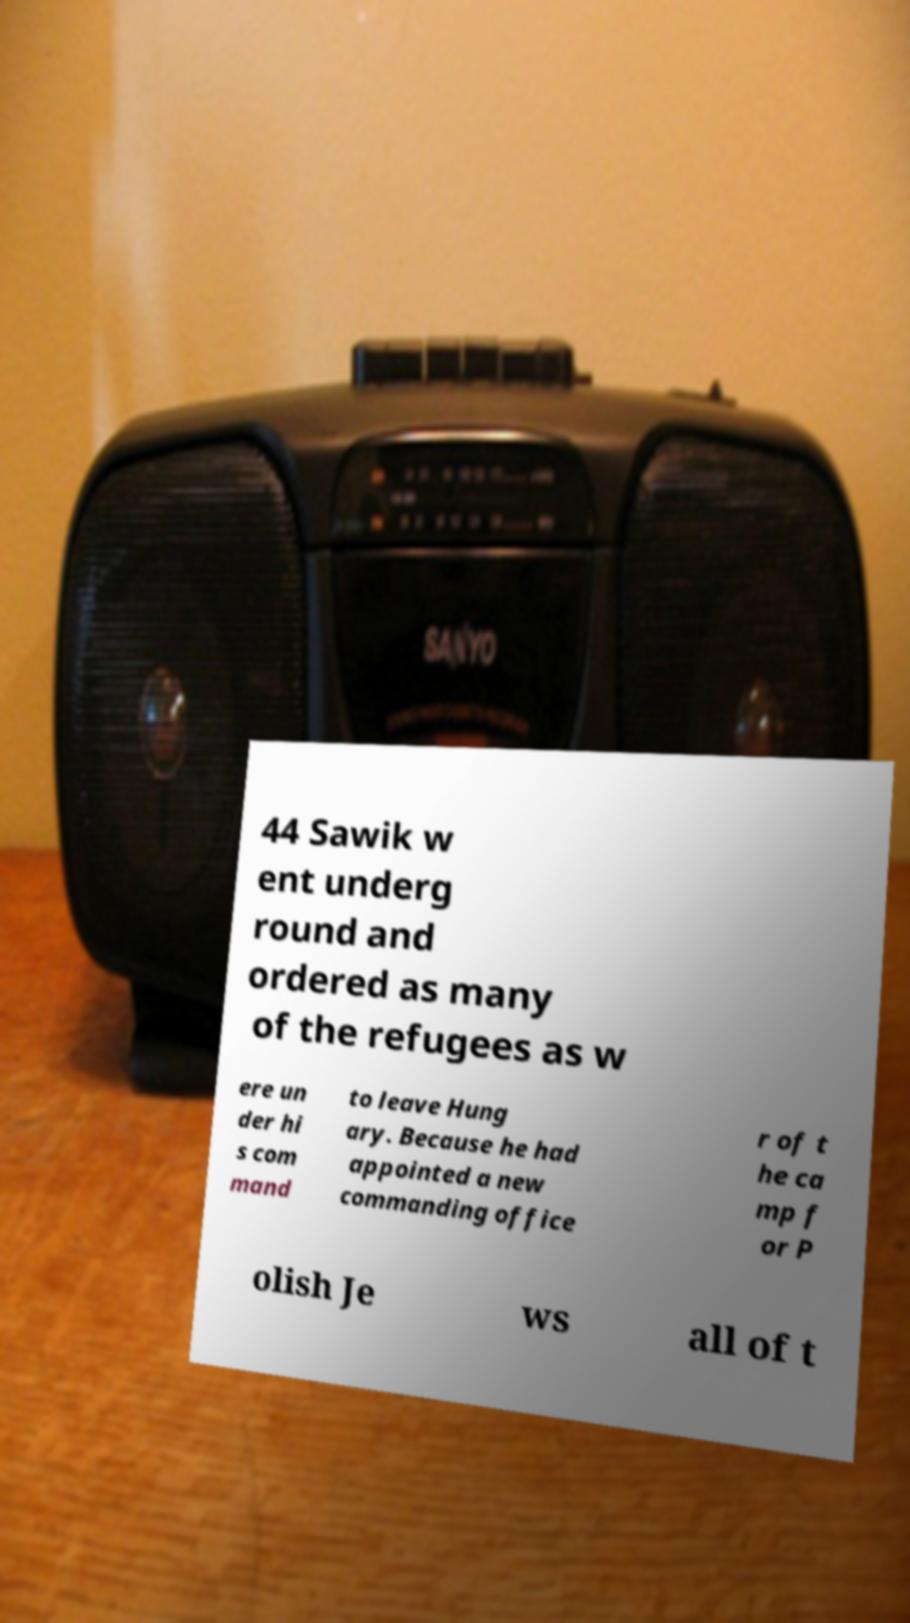Could you assist in decoding the text presented in this image and type it out clearly? 44 Sawik w ent underg round and ordered as many of the refugees as w ere un der hi s com mand to leave Hung ary. Because he had appointed a new commanding office r of t he ca mp f or P olish Je ws all of t 